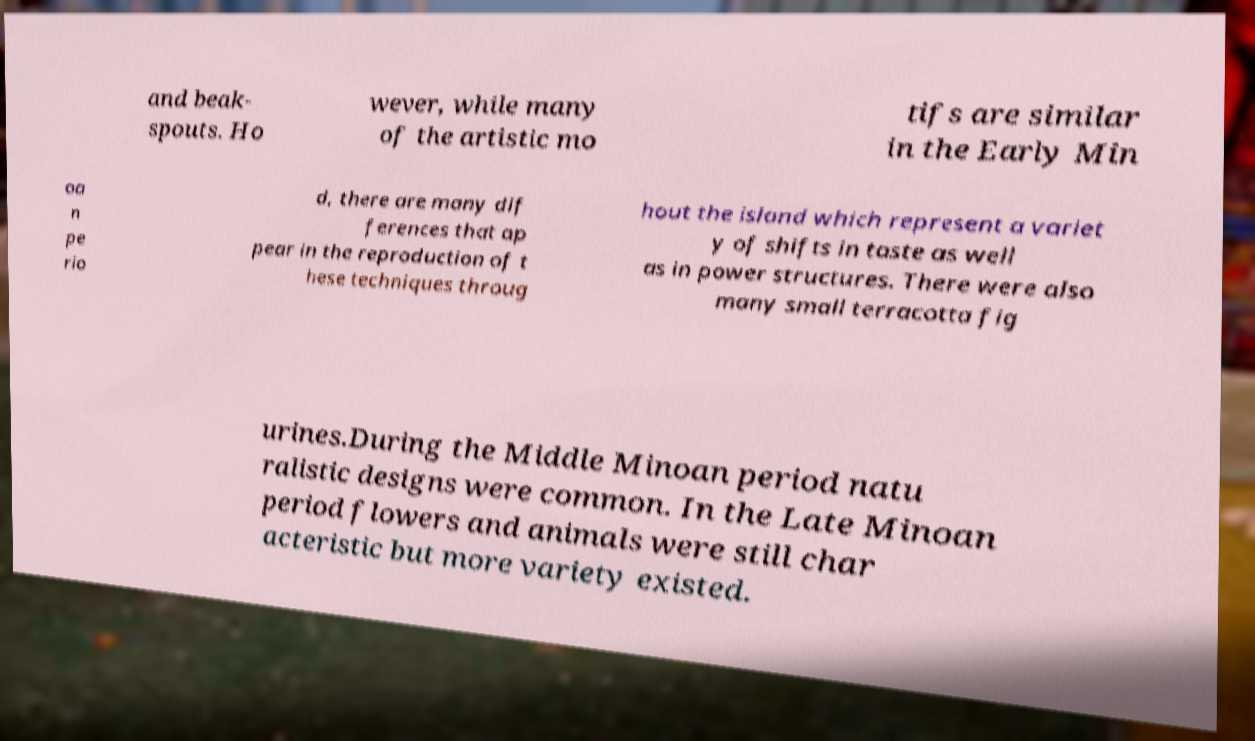For documentation purposes, I need the text within this image transcribed. Could you provide that? and beak- spouts. Ho wever, while many of the artistic mo tifs are similar in the Early Min oa n pe rio d, there are many dif ferences that ap pear in the reproduction of t hese techniques throug hout the island which represent a variet y of shifts in taste as well as in power structures. There were also many small terracotta fig urines.During the Middle Minoan period natu ralistic designs were common. In the Late Minoan period flowers and animals were still char acteristic but more variety existed. 